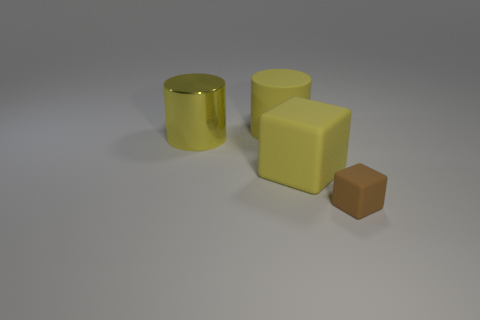There is a rubber thing that is behind the brown matte thing and right of the rubber cylinder; how big is it? The rubber object in question appears to be relatively small when compared to the other objects in the image, specifically the rubber cylinder and the brown matte cube. Without precise measurements, it is challenging to provide an exact size, but its dimensions are noticeably less than the cylinder and the cube adjacent to it. 